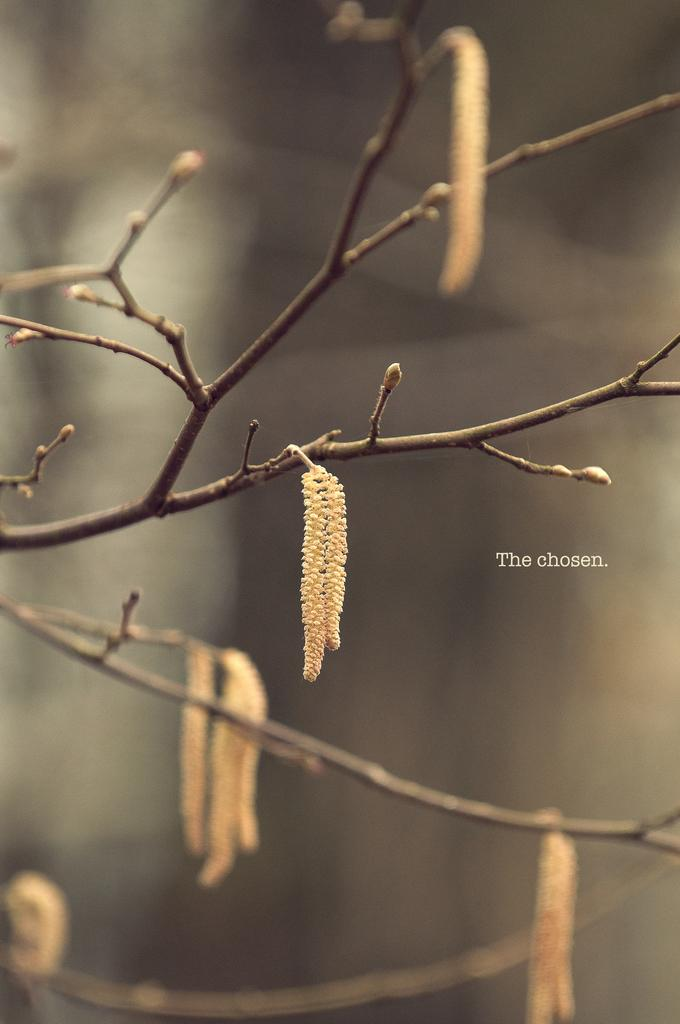What type of plants can be seen in the image? There are flowers in the image. What part of a tree is visible in the image? There are branches of a tree in the image. How would you describe the background of the image? The background of the image is blurry. Where is the text located in the image? The text is on the right side of the image. What type of produce is being sold in the image? There is no produce visible in the image; it features flowers and tree branches. Can you tell me if any crimes are being committed in the image? There is no indication of any crime in the image. 